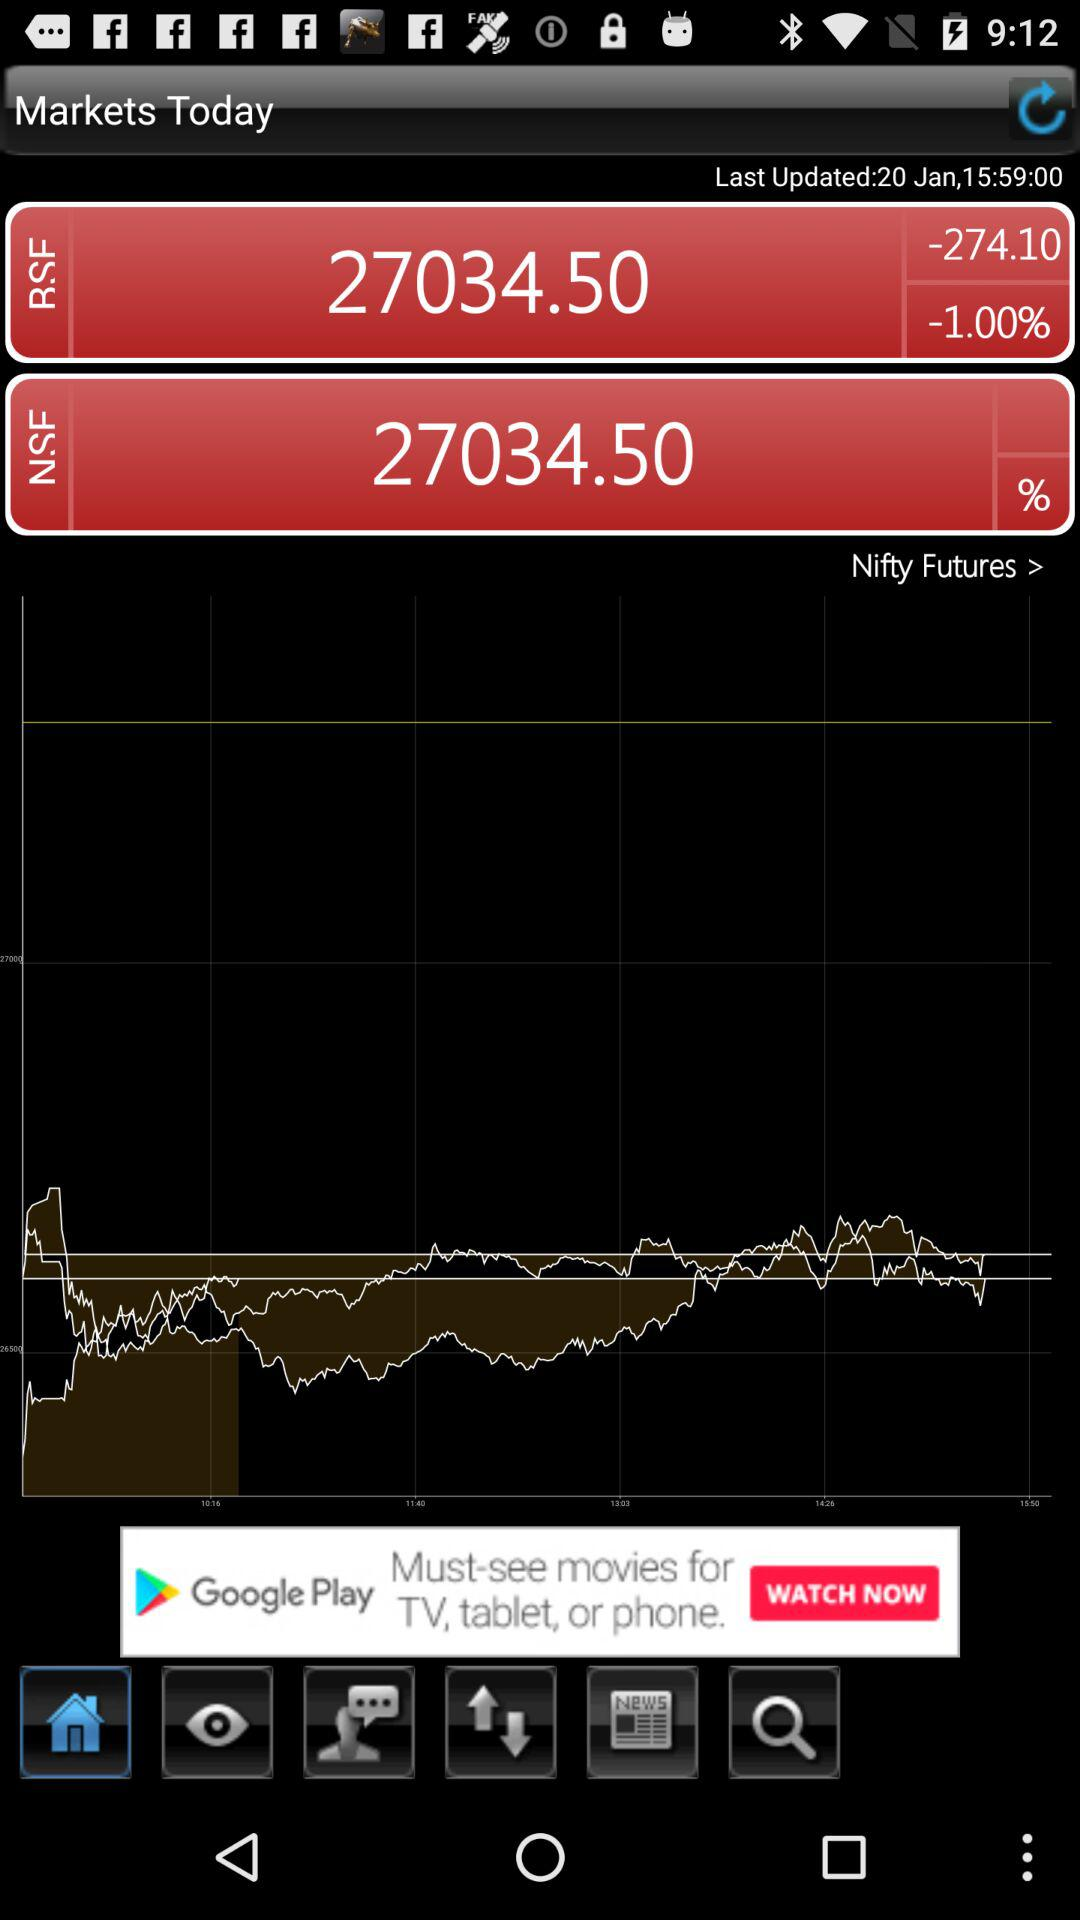How many people have downloaded "Markets Today"?
When the provided information is insufficient, respond with <no answer>. <no answer> 